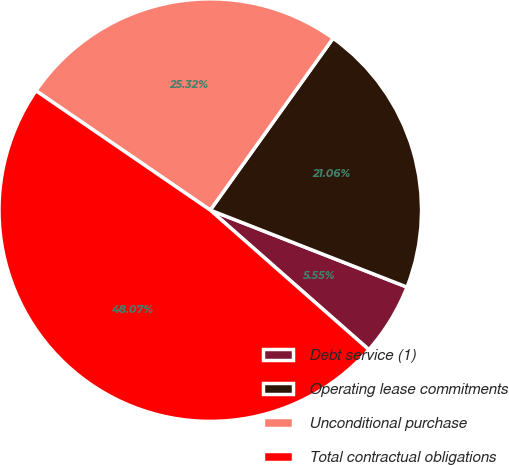Convert chart. <chart><loc_0><loc_0><loc_500><loc_500><pie_chart><fcel>Debt service (1)<fcel>Operating lease commitments<fcel>Unconditional purchase<fcel>Total contractual obligations<nl><fcel>5.55%<fcel>21.06%<fcel>25.32%<fcel>48.07%<nl></chart> 